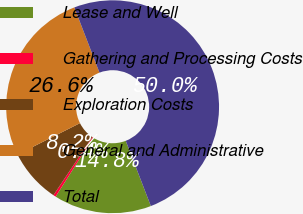<chart> <loc_0><loc_0><loc_500><loc_500><pie_chart><fcel>Lease and Well<fcel>Gathering and Processing Costs<fcel>Exploration Costs<fcel>General and Administrative<fcel>Total<nl><fcel>14.84%<fcel>0.39%<fcel>8.2%<fcel>26.56%<fcel>50.0%<nl></chart> 